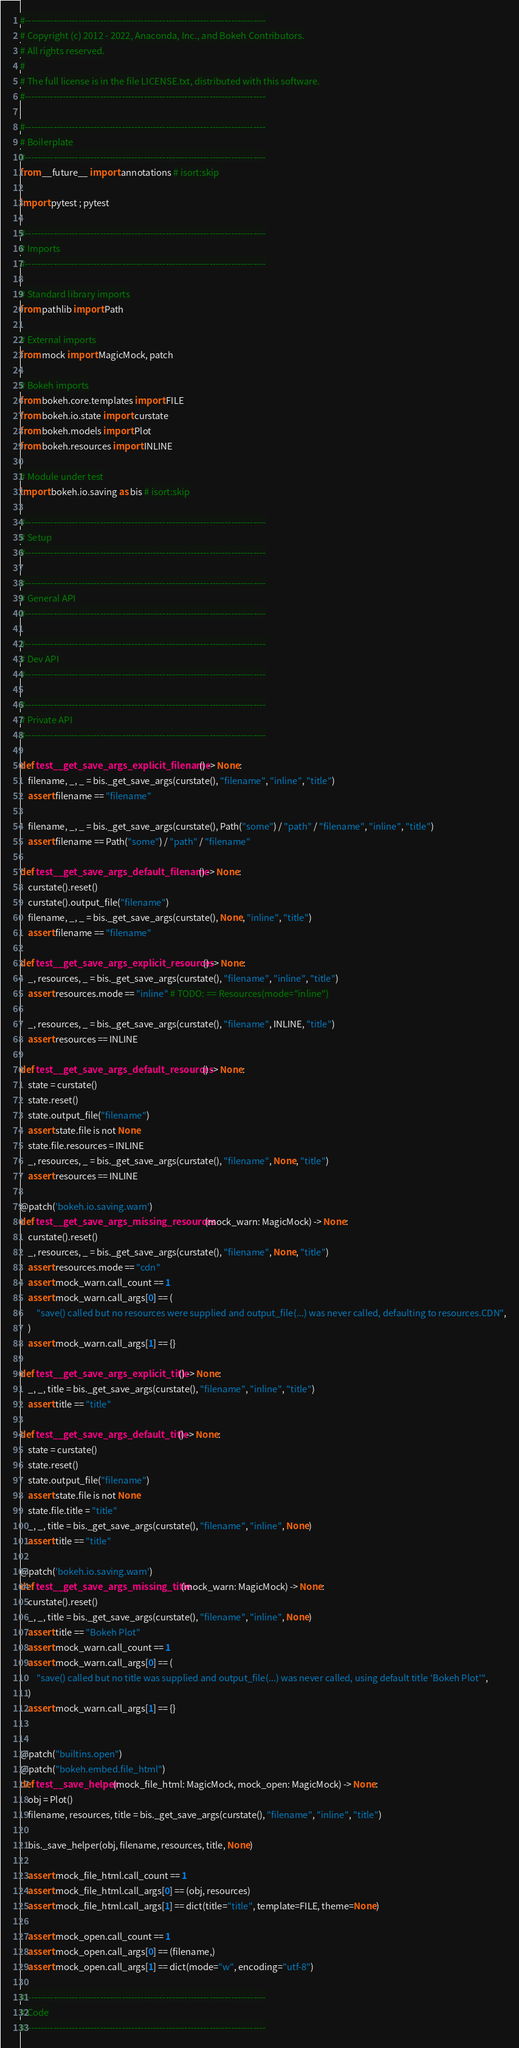<code> <loc_0><loc_0><loc_500><loc_500><_Python_>#-----------------------------------------------------------------------------
# Copyright (c) 2012 - 2022, Anaconda, Inc., and Bokeh Contributors.
# All rights reserved.
#
# The full license is in the file LICENSE.txt, distributed with this software.
#-----------------------------------------------------------------------------

#-----------------------------------------------------------------------------
# Boilerplate
#-----------------------------------------------------------------------------
from __future__ import annotations # isort:skip

import pytest ; pytest

#-----------------------------------------------------------------------------
# Imports
#-----------------------------------------------------------------------------

# Standard library imports
from pathlib import Path

# External imports
from mock import MagicMock, patch

# Bokeh imports
from bokeh.core.templates import FILE
from bokeh.io.state import curstate
from bokeh.models import Plot
from bokeh.resources import INLINE

# Module under test
import bokeh.io.saving as bis # isort:skip

#-----------------------------------------------------------------------------
# Setup
#-----------------------------------------------------------------------------

#-----------------------------------------------------------------------------
# General API
#-----------------------------------------------------------------------------

#-----------------------------------------------------------------------------
# Dev API
#-----------------------------------------------------------------------------

#-----------------------------------------------------------------------------
# Private API
#-----------------------------------------------------------------------------

def test__get_save_args_explicit_filename() -> None:
    filename, _, _ = bis._get_save_args(curstate(), "filename", "inline", "title")
    assert filename == "filename"

    filename, _, _ = bis._get_save_args(curstate(), Path("some") / "path" / "filename", "inline", "title")
    assert filename == Path("some") / "path" / "filename"

def test__get_save_args_default_filename() -> None:
    curstate().reset()
    curstate().output_file("filename")
    filename, _, _ = bis._get_save_args(curstate(), None, "inline", "title")
    assert filename == "filename"

def test__get_save_args_explicit_resources() -> None:
    _, resources, _ = bis._get_save_args(curstate(), "filename", "inline", "title")
    assert resources.mode == "inline" # TODO: == Resources(mode="inline")

    _, resources, _ = bis._get_save_args(curstate(), "filename", INLINE, "title")
    assert resources == INLINE

def test__get_save_args_default_resources() -> None:
    state = curstate()
    state.reset()
    state.output_file("filename")
    assert state.file is not None
    state.file.resources = INLINE
    _, resources, _ = bis._get_save_args(curstate(), "filename", None, "title")
    assert resources == INLINE

@patch('bokeh.io.saving.warn')
def test__get_save_args_missing_resources(mock_warn: MagicMock) -> None:
    curstate().reset()
    _, resources, _ = bis._get_save_args(curstate(), "filename", None, "title")
    assert resources.mode == "cdn"
    assert mock_warn.call_count == 1
    assert mock_warn.call_args[0] == (
        "save() called but no resources were supplied and output_file(...) was never called, defaulting to resources.CDN",
    )
    assert mock_warn.call_args[1] == {}

def test__get_save_args_explicit_title() -> None:
    _, _, title = bis._get_save_args(curstate(), "filename", "inline", "title")
    assert title == "title"

def test__get_save_args_default_title() -> None:
    state = curstate()
    state.reset()
    state.output_file("filename")
    assert state.file is not None
    state.file.title = "title"
    _, _, title = bis._get_save_args(curstate(), "filename", "inline", None)
    assert title == "title"

@patch('bokeh.io.saving.warn')
def test__get_save_args_missing_title(mock_warn: MagicMock) -> None:
    curstate().reset()
    _, _, title = bis._get_save_args(curstate(), "filename", "inline", None)
    assert title == "Bokeh Plot"
    assert mock_warn.call_count == 1
    assert mock_warn.call_args[0] == (
        "save() called but no title was supplied and output_file(...) was never called, using default title 'Bokeh Plot'",
    )
    assert mock_warn.call_args[1] == {}


@patch("builtins.open")
@patch("bokeh.embed.file_html")
def test__save_helper(mock_file_html: MagicMock, mock_open: MagicMock) -> None:
    obj = Plot()
    filename, resources, title = bis._get_save_args(curstate(), "filename", "inline", "title")

    bis._save_helper(obj, filename, resources, title, None)

    assert mock_file_html.call_count == 1
    assert mock_file_html.call_args[0] == (obj, resources)
    assert mock_file_html.call_args[1] == dict(title="title", template=FILE, theme=None)

    assert mock_open.call_count == 1
    assert mock_open.call_args[0] == (filename,)
    assert mock_open.call_args[1] == dict(mode="w", encoding="utf-8")

#-----------------------------------------------------------------------------
# Code
#-----------------------------------------------------------------------------
</code> 